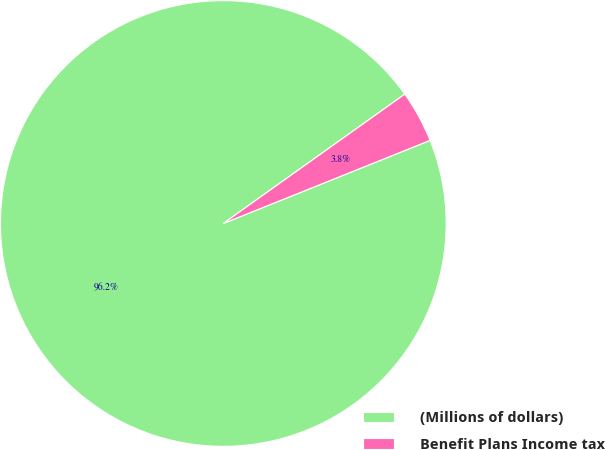Convert chart. <chart><loc_0><loc_0><loc_500><loc_500><pie_chart><fcel>(Millions of dollars)<fcel>Benefit Plans Income tax<nl><fcel>96.23%<fcel>3.77%<nl></chart> 